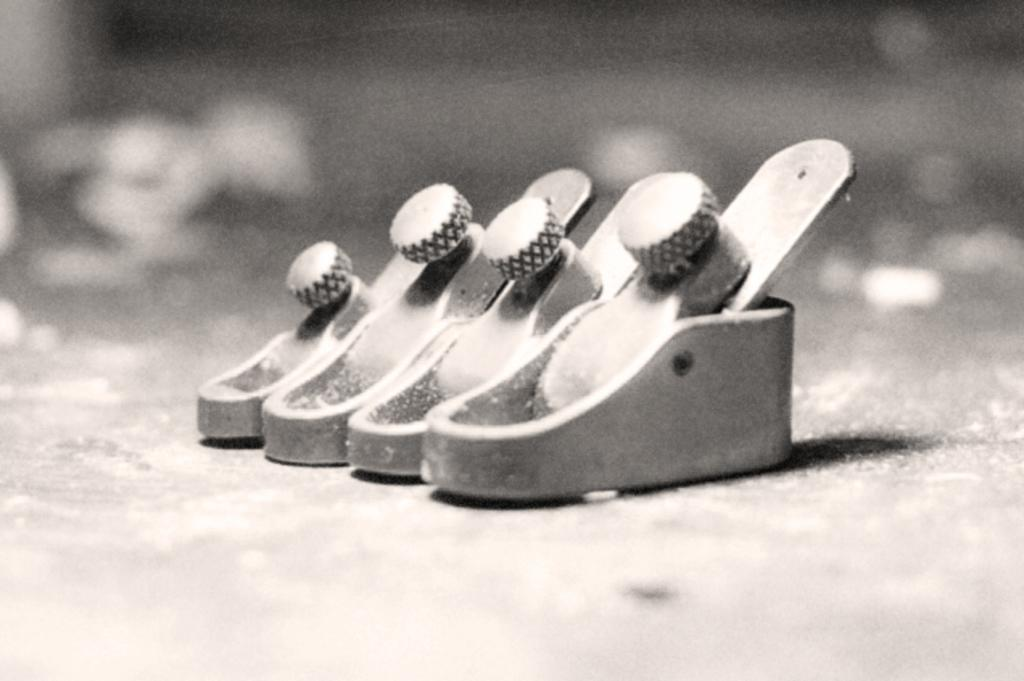What can be seen in the image? There are objects in the image. Can you describe the background of the image? The background of the image is blurred. Where is the sheet used in the image? There is no sheet present in the image. What type of shoe can be seen on the objects in the image? There are no shoes present in the image. 